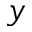<formula> <loc_0><loc_0><loc_500><loc_500>y</formula> 